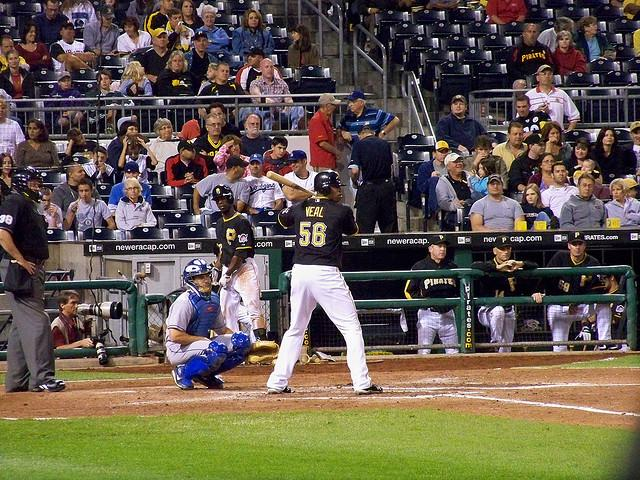What can you obtain from the website advertised? hats 